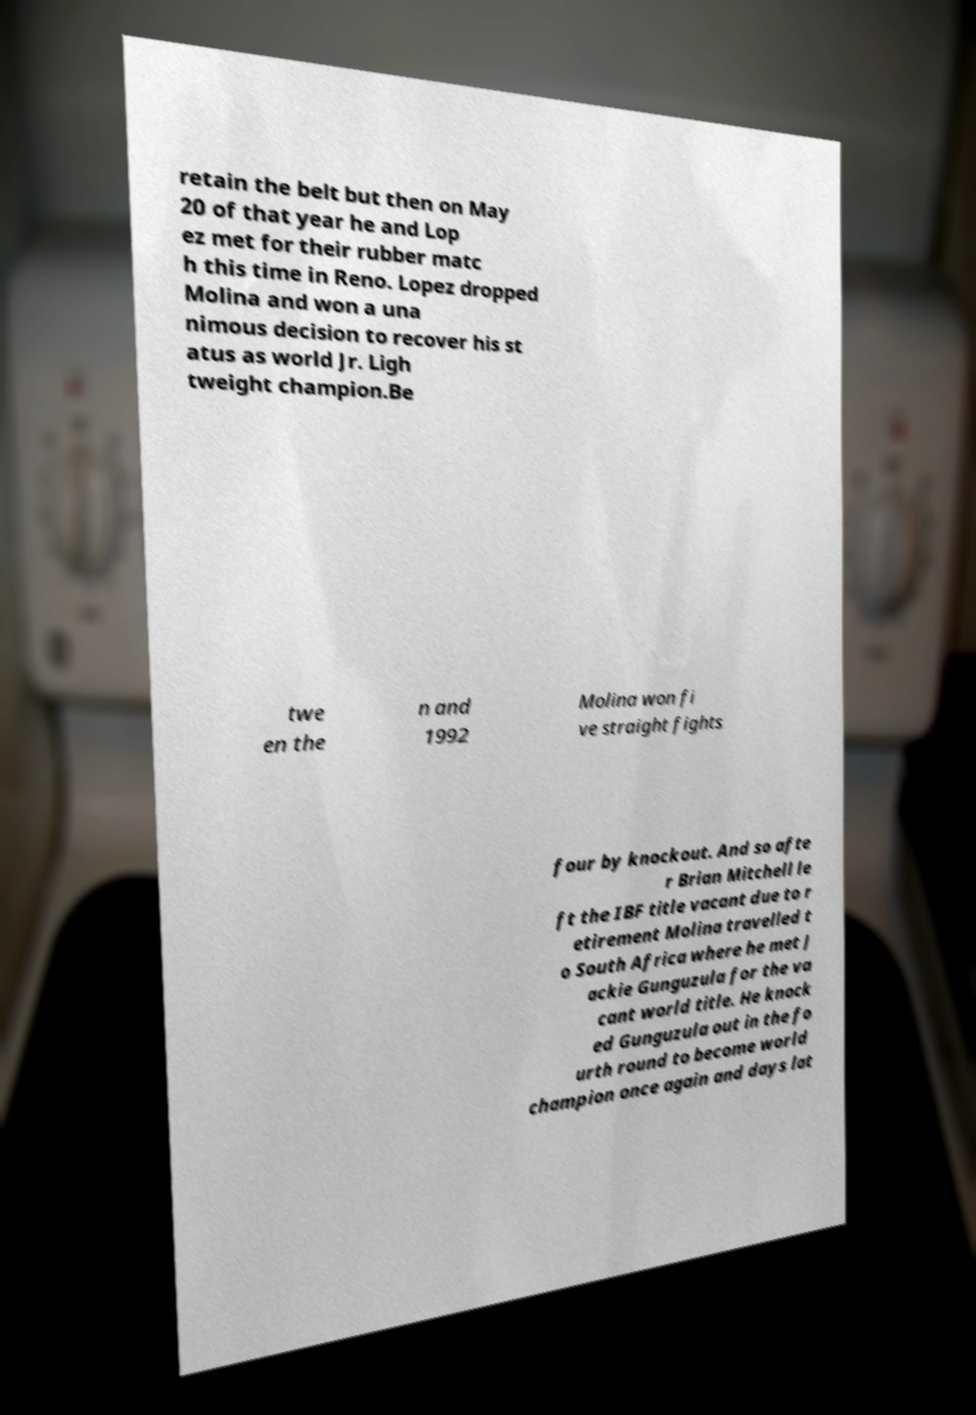Please identify and transcribe the text found in this image. retain the belt but then on May 20 of that year he and Lop ez met for their rubber matc h this time in Reno. Lopez dropped Molina and won a una nimous decision to recover his st atus as world Jr. Ligh tweight champion.Be twe en the n and 1992 Molina won fi ve straight fights four by knockout. And so afte r Brian Mitchell le ft the IBF title vacant due to r etirement Molina travelled t o South Africa where he met J ackie Gunguzula for the va cant world title. He knock ed Gunguzula out in the fo urth round to become world champion once again and days lat 